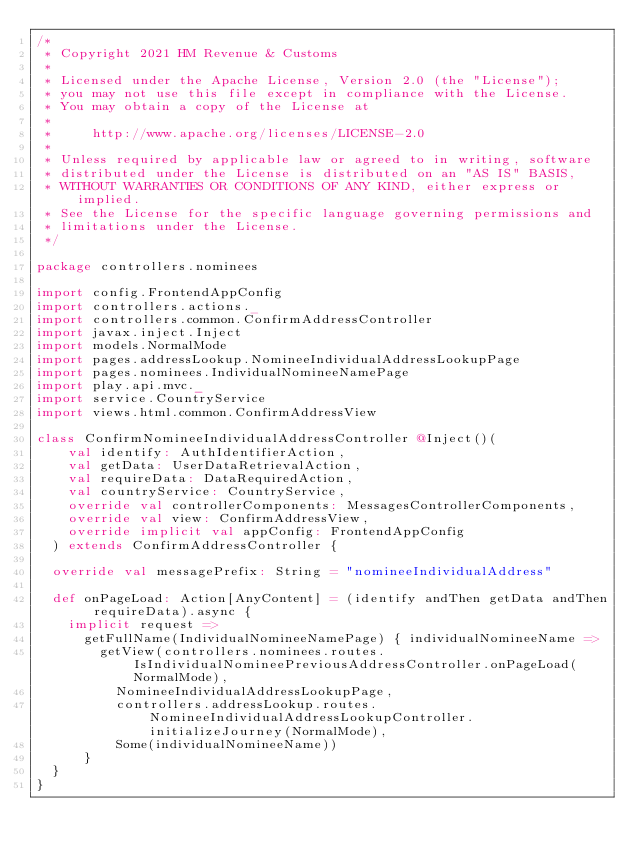<code> <loc_0><loc_0><loc_500><loc_500><_Scala_>/*
 * Copyright 2021 HM Revenue & Customs
 *
 * Licensed under the Apache License, Version 2.0 (the "License");
 * you may not use this file except in compliance with the License.
 * You may obtain a copy of the License at
 *
 *     http://www.apache.org/licenses/LICENSE-2.0
 *
 * Unless required by applicable law or agreed to in writing, software
 * distributed under the License is distributed on an "AS IS" BASIS,
 * WITHOUT WARRANTIES OR CONDITIONS OF ANY KIND, either express or implied.
 * See the License for the specific language governing permissions and
 * limitations under the License.
 */

package controllers.nominees

import config.FrontendAppConfig
import controllers.actions._
import controllers.common.ConfirmAddressController
import javax.inject.Inject
import models.NormalMode
import pages.addressLookup.NomineeIndividualAddressLookupPage
import pages.nominees.IndividualNomineeNamePage
import play.api.mvc._
import service.CountryService
import views.html.common.ConfirmAddressView

class ConfirmNomineeIndividualAddressController @Inject()(
    val identify: AuthIdentifierAction,
    val getData: UserDataRetrievalAction,
    val requireData: DataRequiredAction,
    val countryService: CountryService,
    override val controllerComponents: MessagesControllerComponents,
    override val view: ConfirmAddressView,
    override implicit val appConfig: FrontendAppConfig
  ) extends ConfirmAddressController {

  override val messagePrefix: String = "nomineeIndividualAddress"

  def onPageLoad: Action[AnyContent] = (identify andThen getData andThen requireData).async {
    implicit request =>
      getFullName(IndividualNomineeNamePage) { individualNomineeName =>
        getView(controllers.nominees.routes.IsIndividualNomineePreviousAddressController.onPageLoad(NormalMode),
          NomineeIndividualAddressLookupPage,
          controllers.addressLookup.routes.NomineeIndividualAddressLookupController.initializeJourney(NormalMode),
          Some(individualNomineeName))
      }
  }
}
</code> 